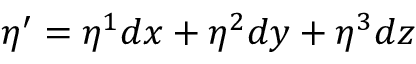Convert formula to latex. <formula><loc_0><loc_0><loc_500><loc_500>\eta ^ { \prime } = \eta ^ { 1 } d x + \eta ^ { 2 } d y + \eta ^ { 3 } d z</formula> 